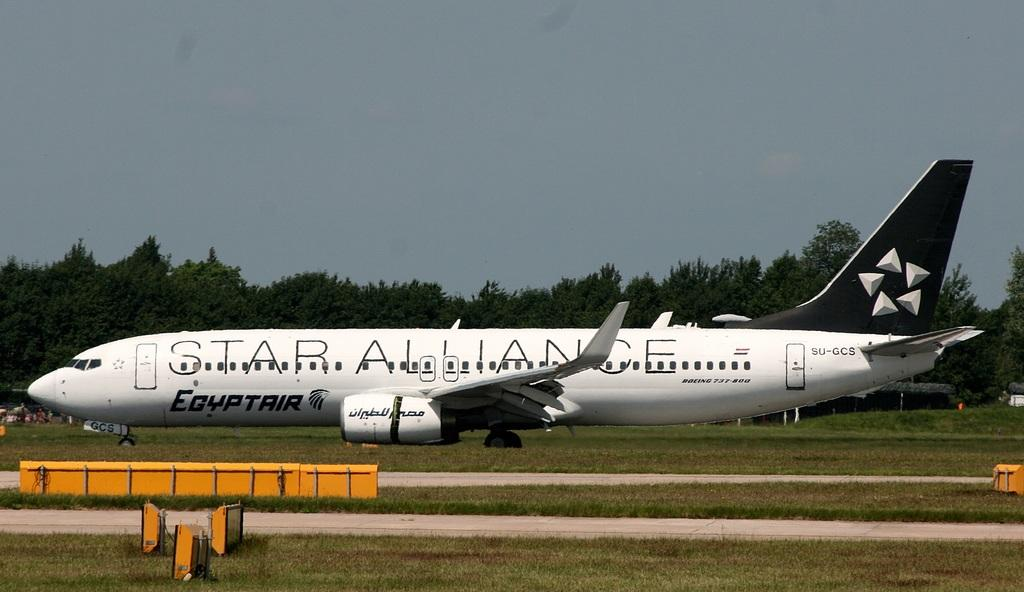Provide a one-sentence caption for the provided image. a white plane that has star alliance on the side of it. 